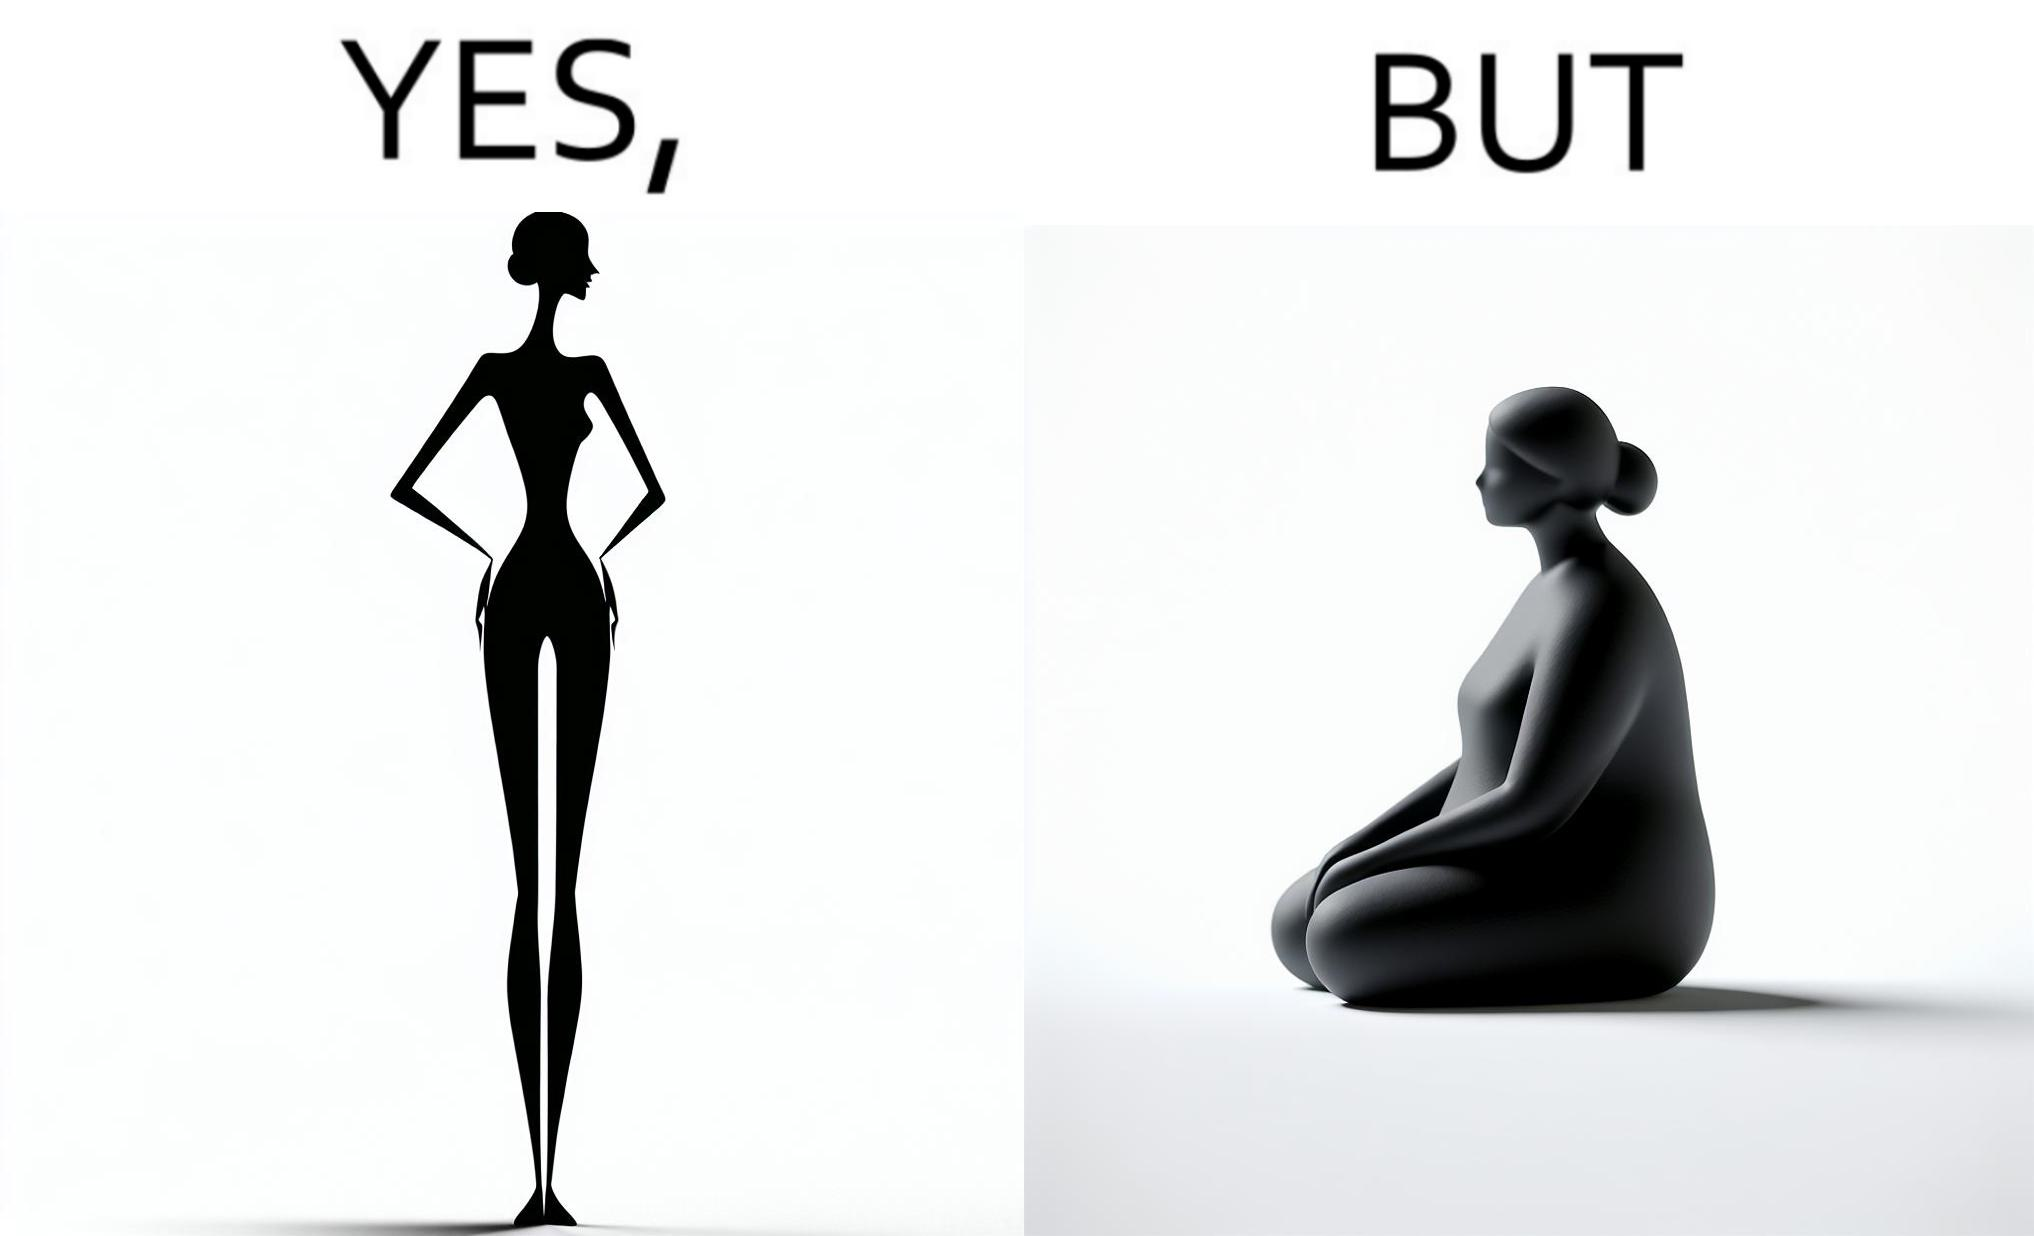Compare the left and right sides of this image. In the left part of the image: a slim woman In the right part of the image: An apparently chubby woman sitting 